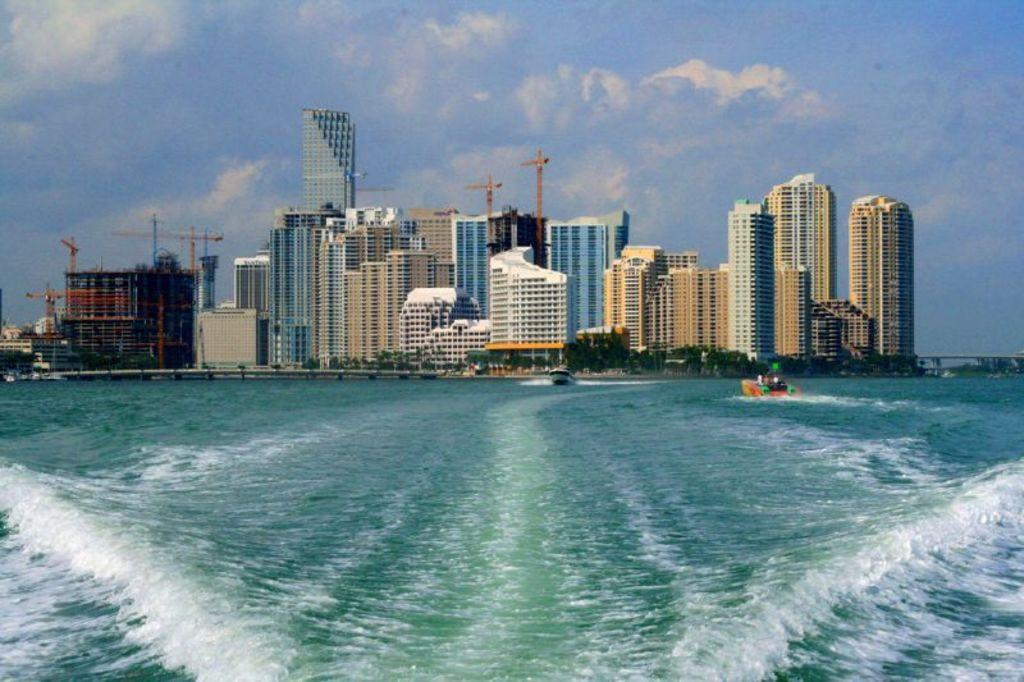What is in the water in the image? There are boats in the water. What can be seen behind the boats? Trees and buildings are visible behind the boats. What is visible in the sky in the image? The sky is visible in the image. Where are the stone statues of dolls and yaks located in the image? There are no stone statues of dolls or yaks present in the image. 